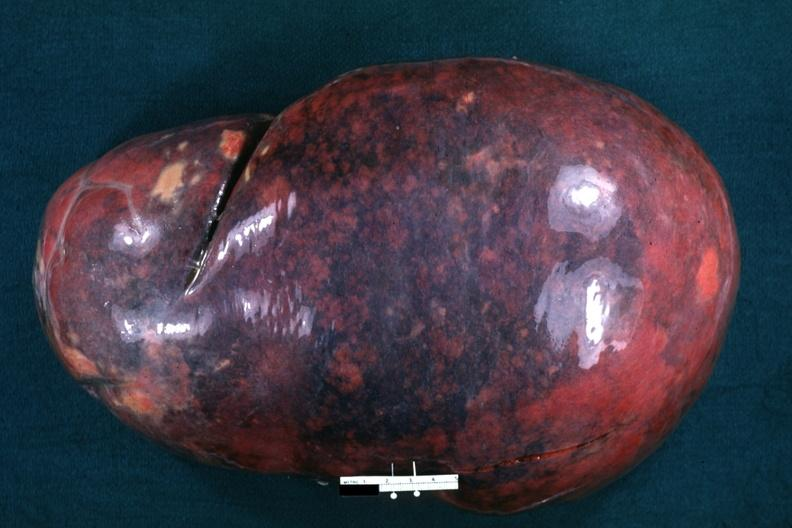what is present?
Answer the question using a single word or phrase. Hematologic 